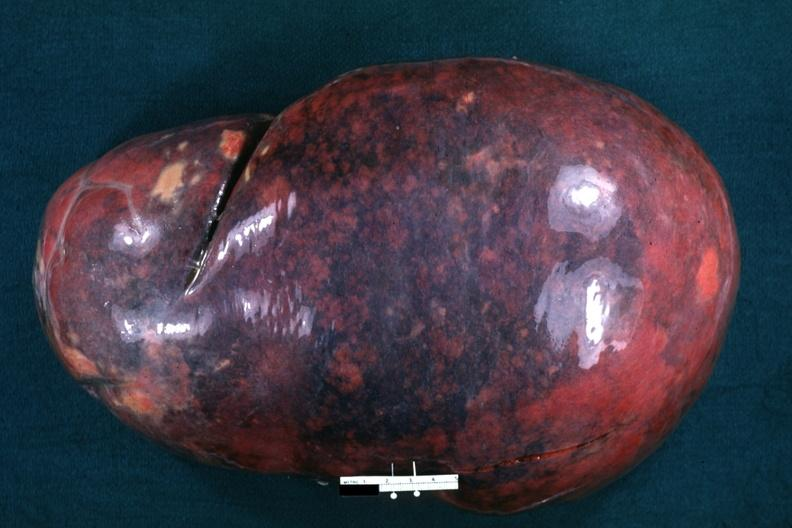what is present?
Answer the question using a single word or phrase. Hematologic 